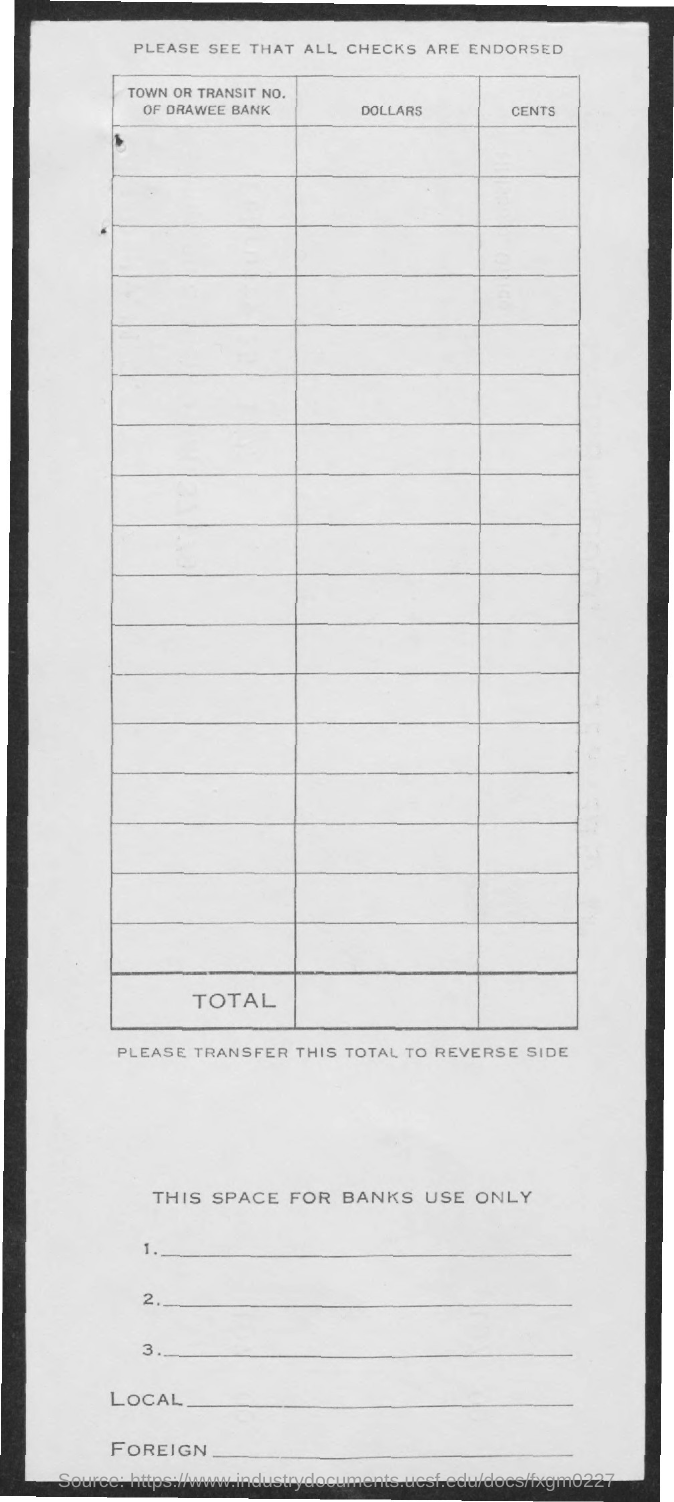What is written above the table?
Provide a short and direct response. Please see that all checks are endorsed. What is written below the table?
Your answer should be compact. Please transfer this total to reverse side. What is the heading for first column?
Offer a very short reply. Town or transit No. Of drawee bank. 